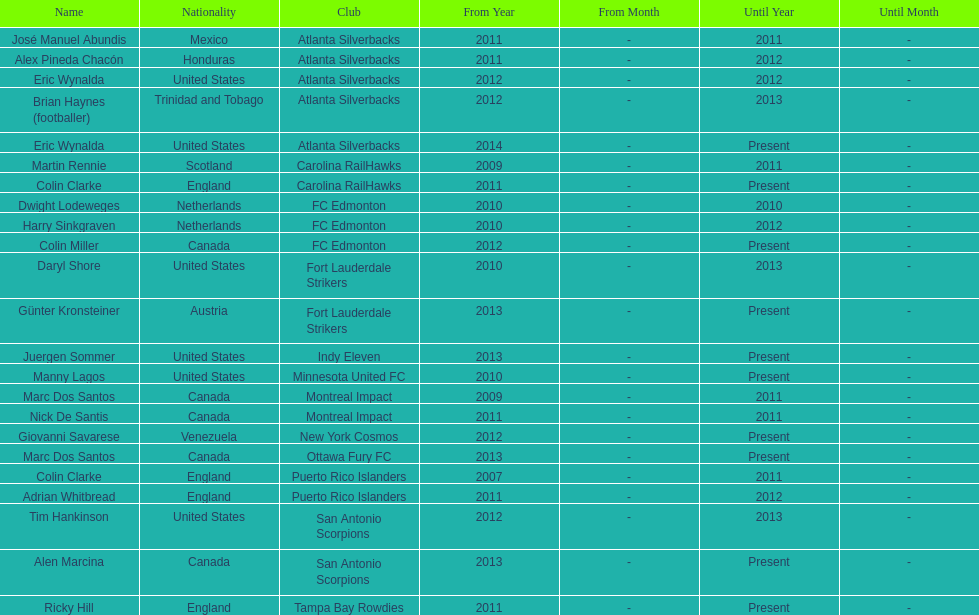How many coaches have coached from america? 6. 